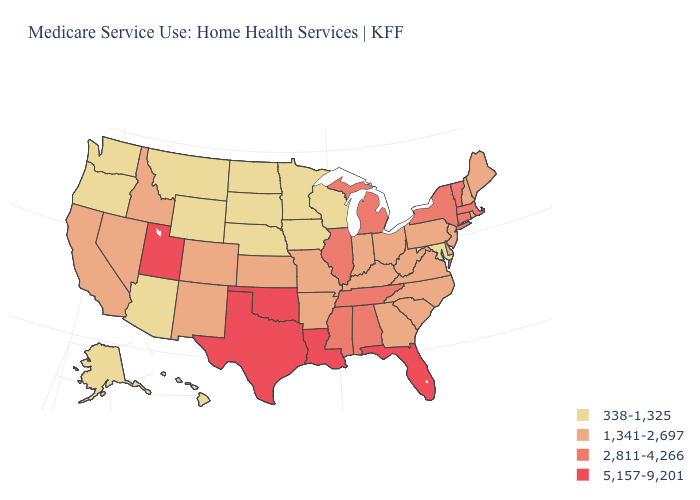Among the states that border Michigan , does Indiana have the highest value?
Quick response, please. Yes. What is the value of South Carolina?
Give a very brief answer. 1,341-2,697. Does Illinois have a higher value than Utah?
Answer briefly. No. What is the lowest value in the South?
Be succinct. 338-1,325. Is the legend a continuous bar?
Short answer required. No. Does Illinois have the lowest value in the USA?
Be succinct. No. What is the value of North Carolina?
Short answer required. 1,341-2,697. How many symbols are there in the legend?
Concise answer only. 4. Name the states that have a value in the range 2,811-4,266?
Answer briefly. Alabama, Connecticut, Illinois, Massachusetts, Michigan, Mississippi, New York, Tennessee, Vermont. Does the map have missing data?
Answer briefly. No. What is the value of Wisconsin?
Quick response, please. 338-1,325. Does the first symbol in the legend represent the smallest category?
Write a very short answer. Yes. Which states have the lowest value in the USA?
Concise answer only. Alaska, Arizona, Hawaii, Iowa, Maryland, Minnesota, Montana, Nebraska, North Dakota, Oregon, South Dakota, Washington, Wisconsin, Wyoming. What is the lowest value in states that border North Dakota?
Be succinct. 338-1,325. What is the value of New Mexico?
Answer briefly. 1,341-2,697. 